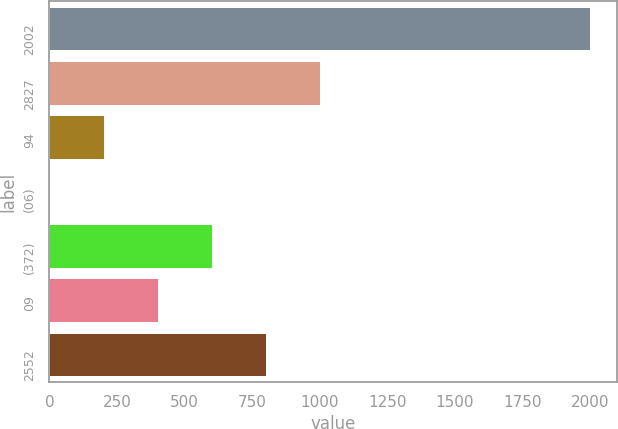Convert chart. <chart><loc_0><loc_0><loc_500><loc_500><bar_chart><fcel>2002<fcel>2827<fcel>94<fcel>(06)<fcel>(372)<fcel>09<fcel>2552<nl><fcel>2001<fcel>1001.2<fcel>201.36<fcel>1.4<fcel>601.28<fcel>401.32<fcel>801.24<nl></chart> 